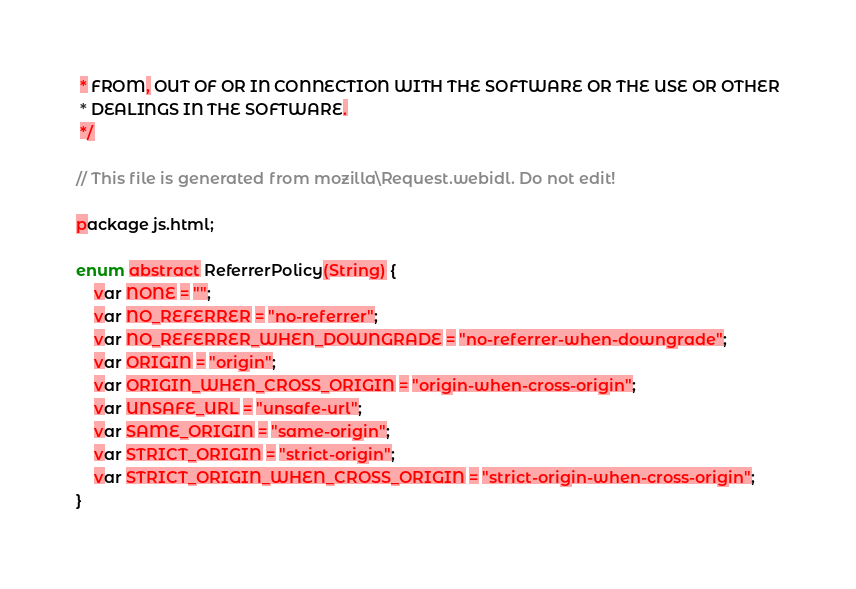Convert code to text. <code><loc_0><loc_0><loc_500><loc_500><_Haxe_> * FROM, OUT OF OR IN CONNECTION WITH THE SOFTWARE OR THE USE OR OTHER
 * DEALINGS IN THE SOFTWARE.
 */

// This file is generated from mozilla\Request.webidl. Do not edit!

package js.html;

enum abstract ReferrerPolicy(String) {
	var NONE = "";
	var NO_REFERRER = "no-referrer";
	var NO_REFERRER_WHEN_DOWNGRADE = "no-referrer-when-downgrade";
	var ORIGIN = "origin";
	var ORIGIN_WHEN_CROSS_ORIGIN = "origin-when-cross-origin";
	var UNSAFE_URL = "unsafe-url";
	var SAME_ORIGIN = "same-origin";
	var STRICT_ORIGIN = "strict-origin";
	var STRICT_ORIGIN_WHEN_CROSS_ORIGIN = "strict-origin-when-cross-origin";
}</code> 